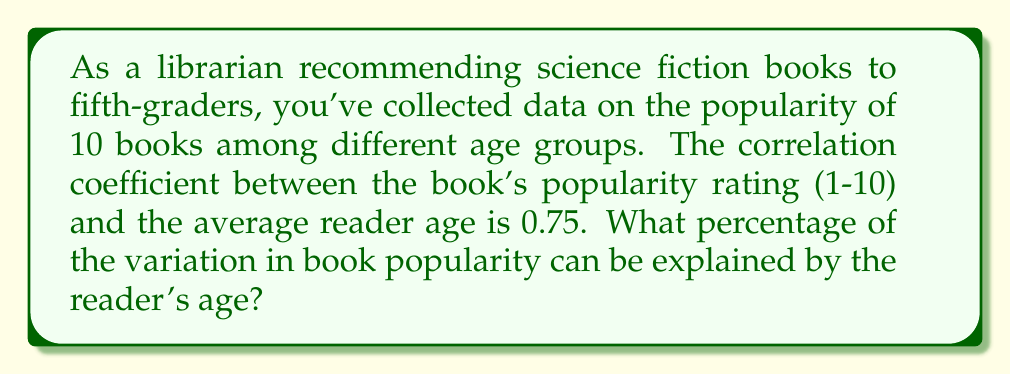Can you solve this math problem? To solve this problem, we need to understand the concept of the coefficient of determination, also known as R-squared. 

Step 1: Recall that the coefficient of determination (R²) is the square of the correlation coefficient (r).

Step 2: We are given that the correlation coefficient (r) is 0.75.

Step 3: Calculate R² by squaring the correlation coefficient:
$$ R^2 = r^2 = (0.75)^2 = 0.5625 $$

Step 4: Convert the R² value to a percentage by multiplying by 100:
$$ 0.5625 \times 100 = 56.25\% $$

The coefficient of determination (R²) represents the proportion of variance in the dependent variable (book popularity) that is predictable from the independent variable (reader age). In this case, 56.25% of the variation in book popularity can be explained by the reader's age.

This means that while there is a moderate to strong relationship between book popularity and reader age, other factors also contribute to a book's popularity among fifth-graders.
Answer: 56.25% 